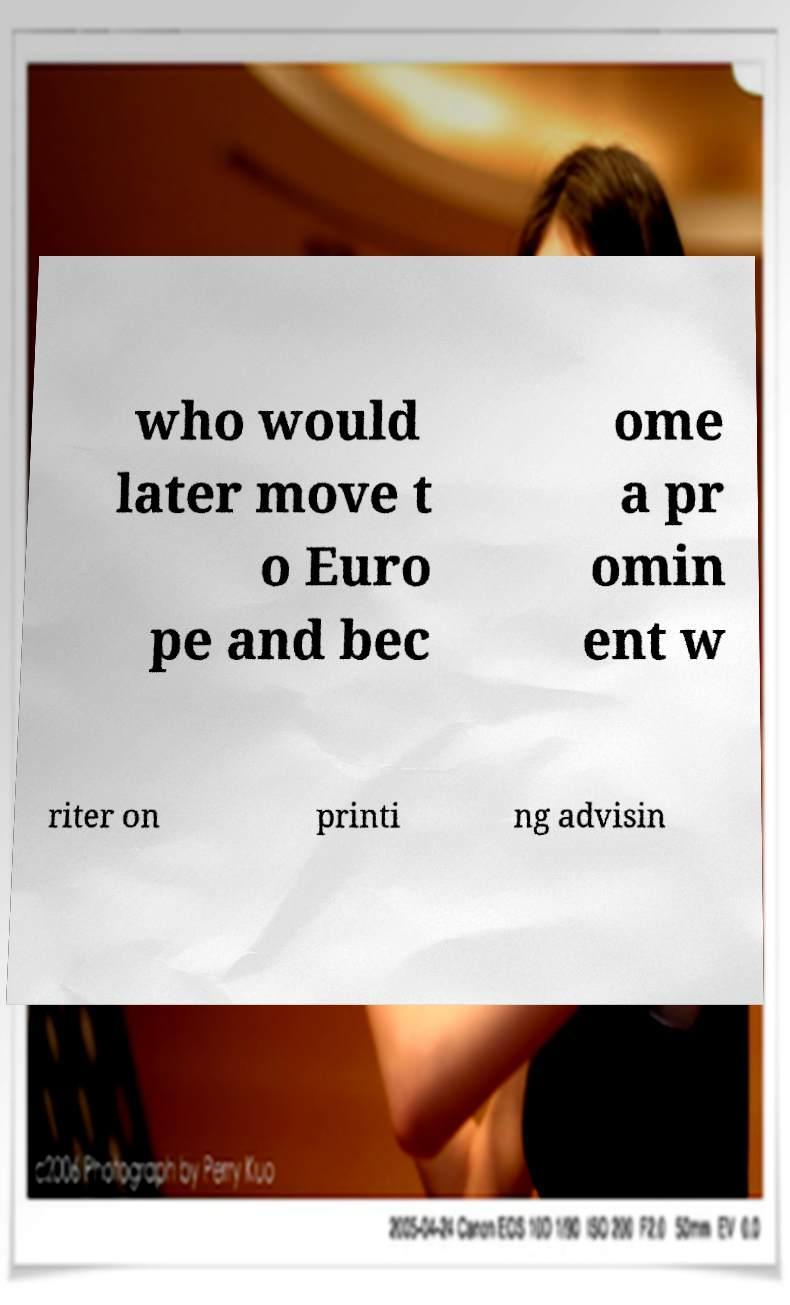For documentation purposes, I need the text within this image transcribed. Could you provide that? who would later move t o Euro pe and bec ome a pr omin ent w riter on printi ng advisin 